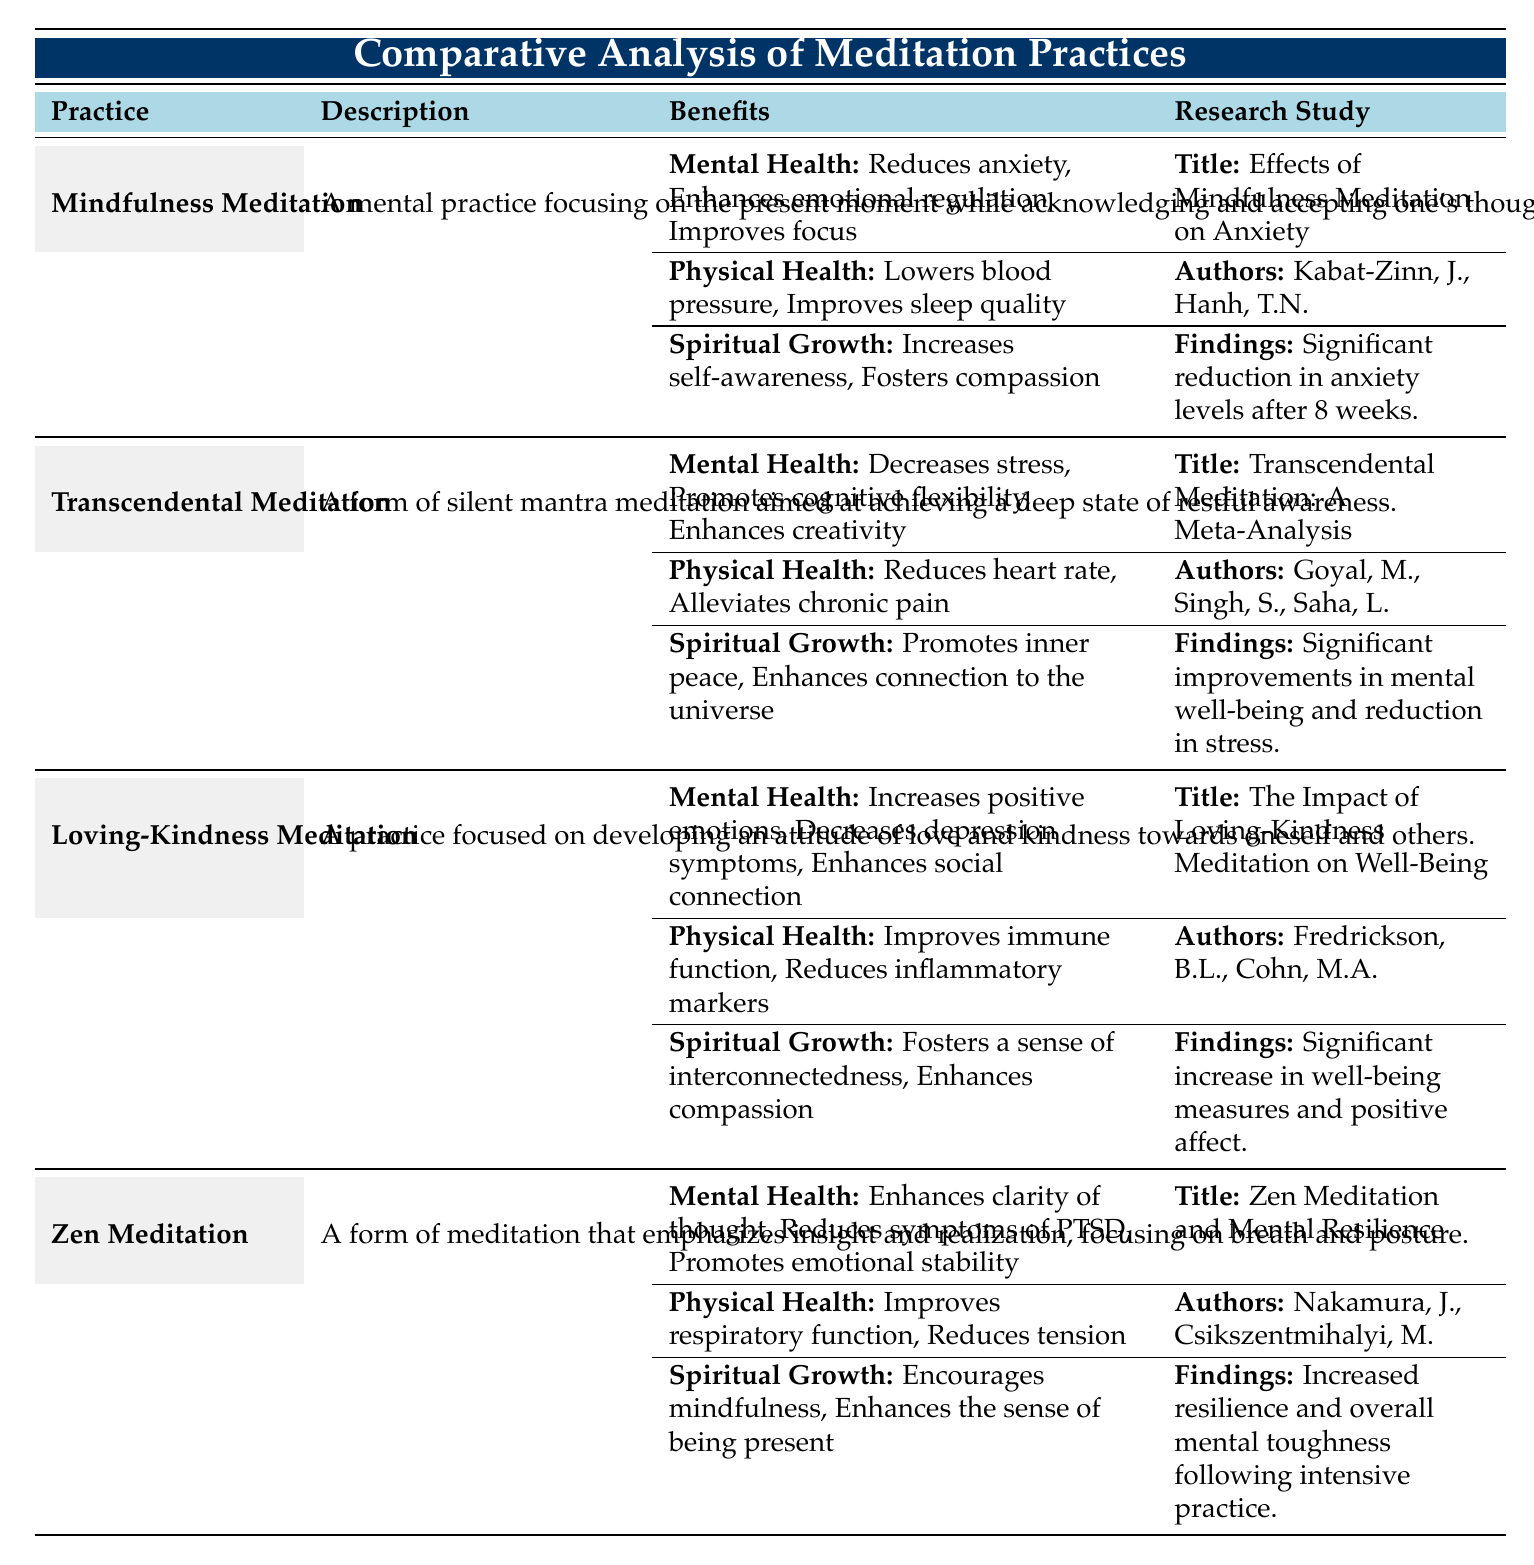What are the main mental health benefits of Mindfulness Meditation? The table lists the mental health benefits of Mindfulness Meditation as reducing anxiety, enhancing emotional regulation, and improving focus. These points can be directly retrieved from the corresponding section in the table.
Answer: Reduces anxiety, enhances emotional regulation, improves focus Which meditation practice is associated with enhancing creativity? According to the table, Transcendental Meditation promotes cognitive flexibility and enhances creativity as part of its mental health benefits. This information is found in the benefits section for Transcendental Meditation.
Answer: Transcendental Meditation Did Loving-Kindness Meditation show a significant impact on increasing positive emotions? The data in the table indicates that Loving-Kindness Meditation increases positive emotions as one of its mental health benefits. This is a direct retrieval from the benefits listed for that meditation practice.
Answer: Yes How many participants were involved in the research study on Zen Meditation? The table specifies that the study on Zen Meditation had a cohort of 80 participants. This detail is included in the research study section for Zen Meditation.
Answer: 80 participants Which meditation practice has the highest number of research participants, and how many were involved? By comparing the cohort sizes listed in each practice’s research study, Transcendental Meditation has the highest number of participants at 200. This requires checking each entry and identifying the maximum cohort value.
Answer: Transcendental Meditation, 200 participants What is the finding regarding Loving-Kindness Meditation's impact on well-being measures? The table shows that the research study on Loving-Kindness Meditation found a significant increase in well-being measures and positive affect, indicating its positive psychological effects. This is stated explicitly in the findings for that meditation practice.
Answer: Significant increase in well-being measures Which meditation practices demonstrate benefits to physical health? The table outlines physical health benefits for each meditation practice: Mindfulness (lowers blood pressure, improves sleep quality), Transcendental (reduces heart rate, alleviates chronic pain), Loving-Kindness (improves immune function, reduces inflammatory markers), and Zen (improves respiratory function, reduces tension). This requires skimming through the physical health sections of each practice.
Answer: All practices listed demonstrate benefits to physical health What are the spiritual growth benefits associated with Zen Meditation? The table notes that Zen Meditation promotes mindfulness and enhances the sense of being present as spiritual growth benefits. This information can be found in the corresponding benefits section specifically related to Zen Meditation.
Answer: Promotes mindfulness, enhances sense of being present 